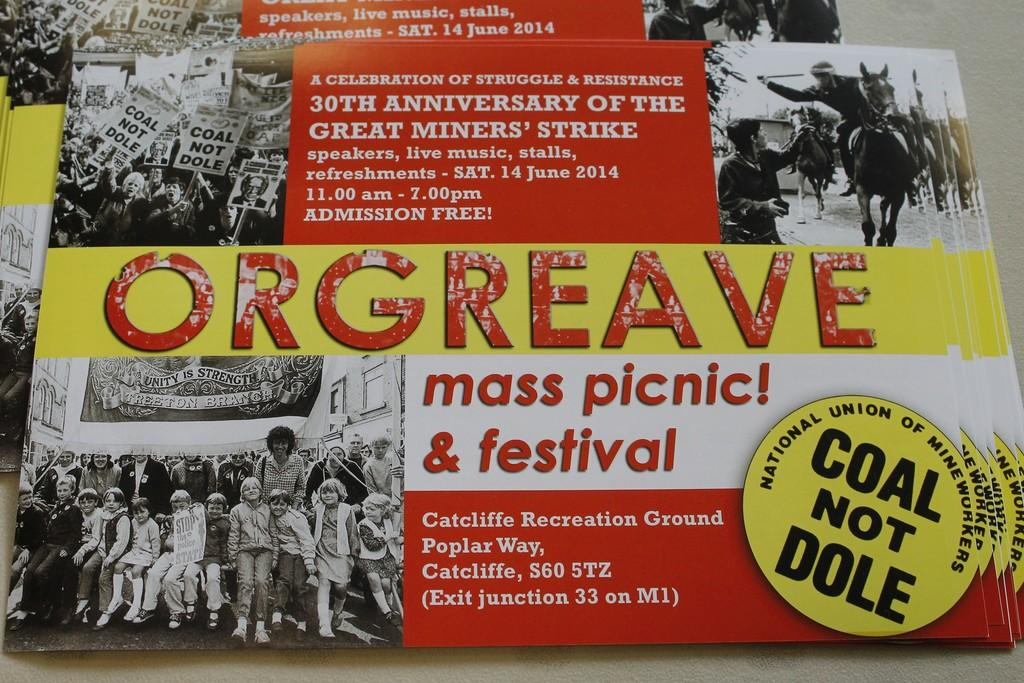<image>
Present a compact description of the photo's key features. A poster for an event commemorating the Great Miners Strike includes black and white photos from the original event. 